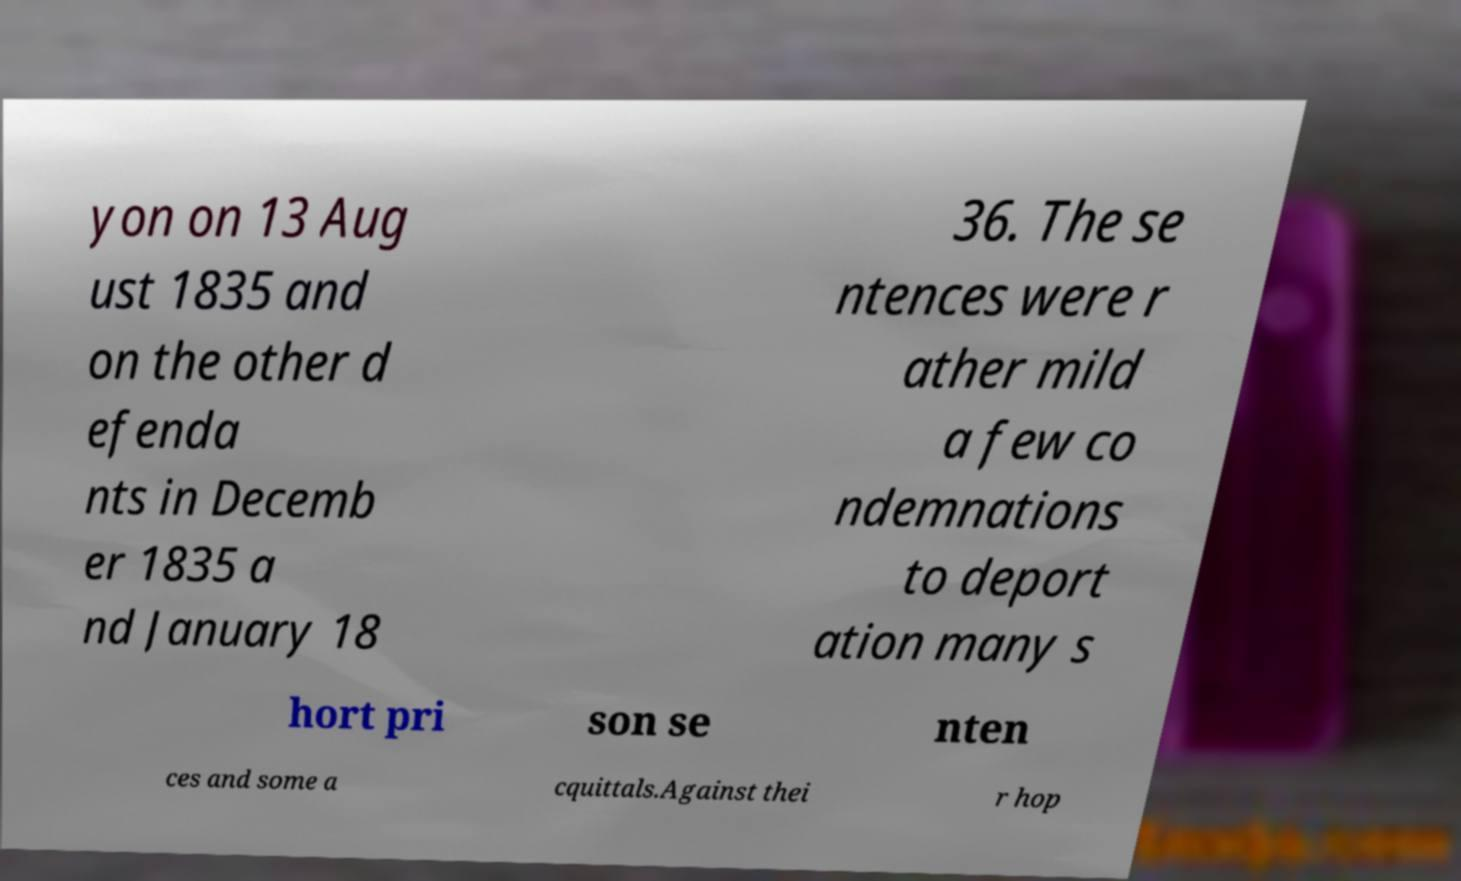Could you assist in decoding the text presented in this image and type it out clearly? yon on 13 Aug ust 1835 and on the other d efenda nts in Decemb er 1835 a nd January 18 36. The se ntences were r ather mild a few co ndemnations to deport ation many s hort pri son se nten ces and some a cquittals.Against thei r hop 